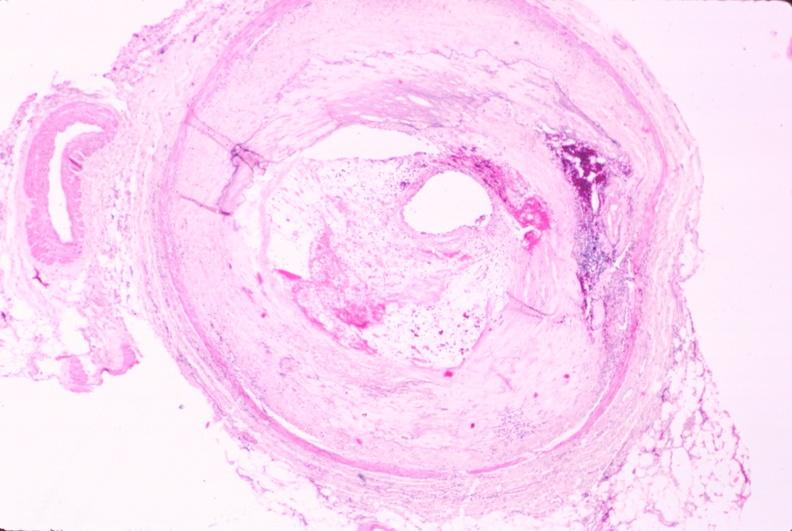what left anterior descending coronary artery?
Answer the question using a single word or phrase. Atherosclerosis 